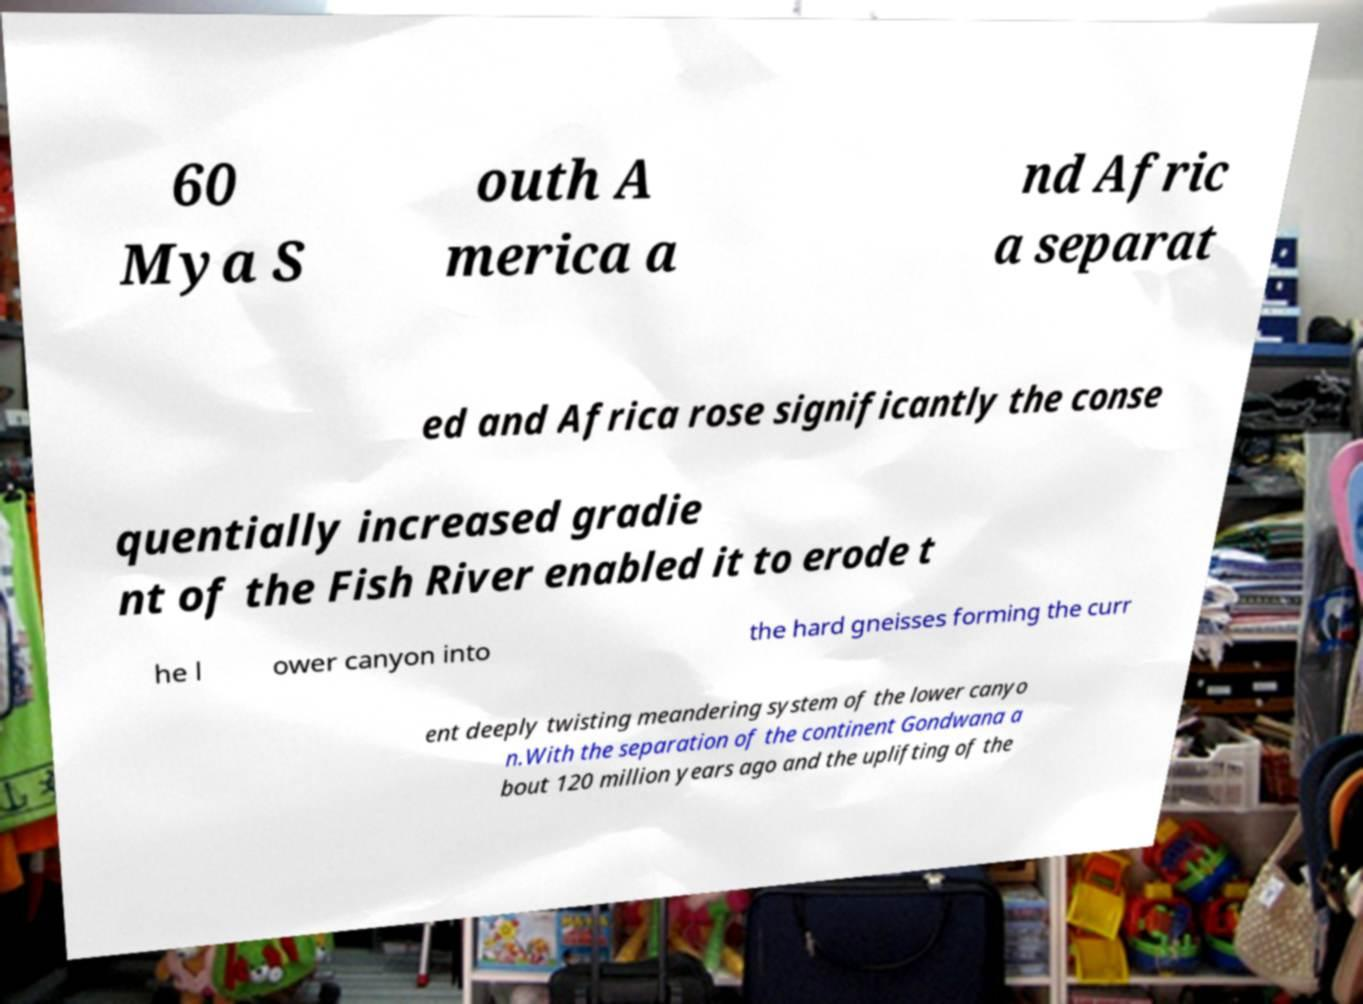For documentation purposes, I need the text within this image transcribed. Could you provide that? 60 Mya S outh A merica a nd Afric a separat ed and Africa rose significantly the conse quentially increased gradie nt of the Fish River enabled it to erode t he l ower canyon into the hard gneisses forming the curr ent deeply twisting meandering system of the lower canyo n.With the separation of the continent Gondwana a bout 120 million years ago and the uplifting of the 